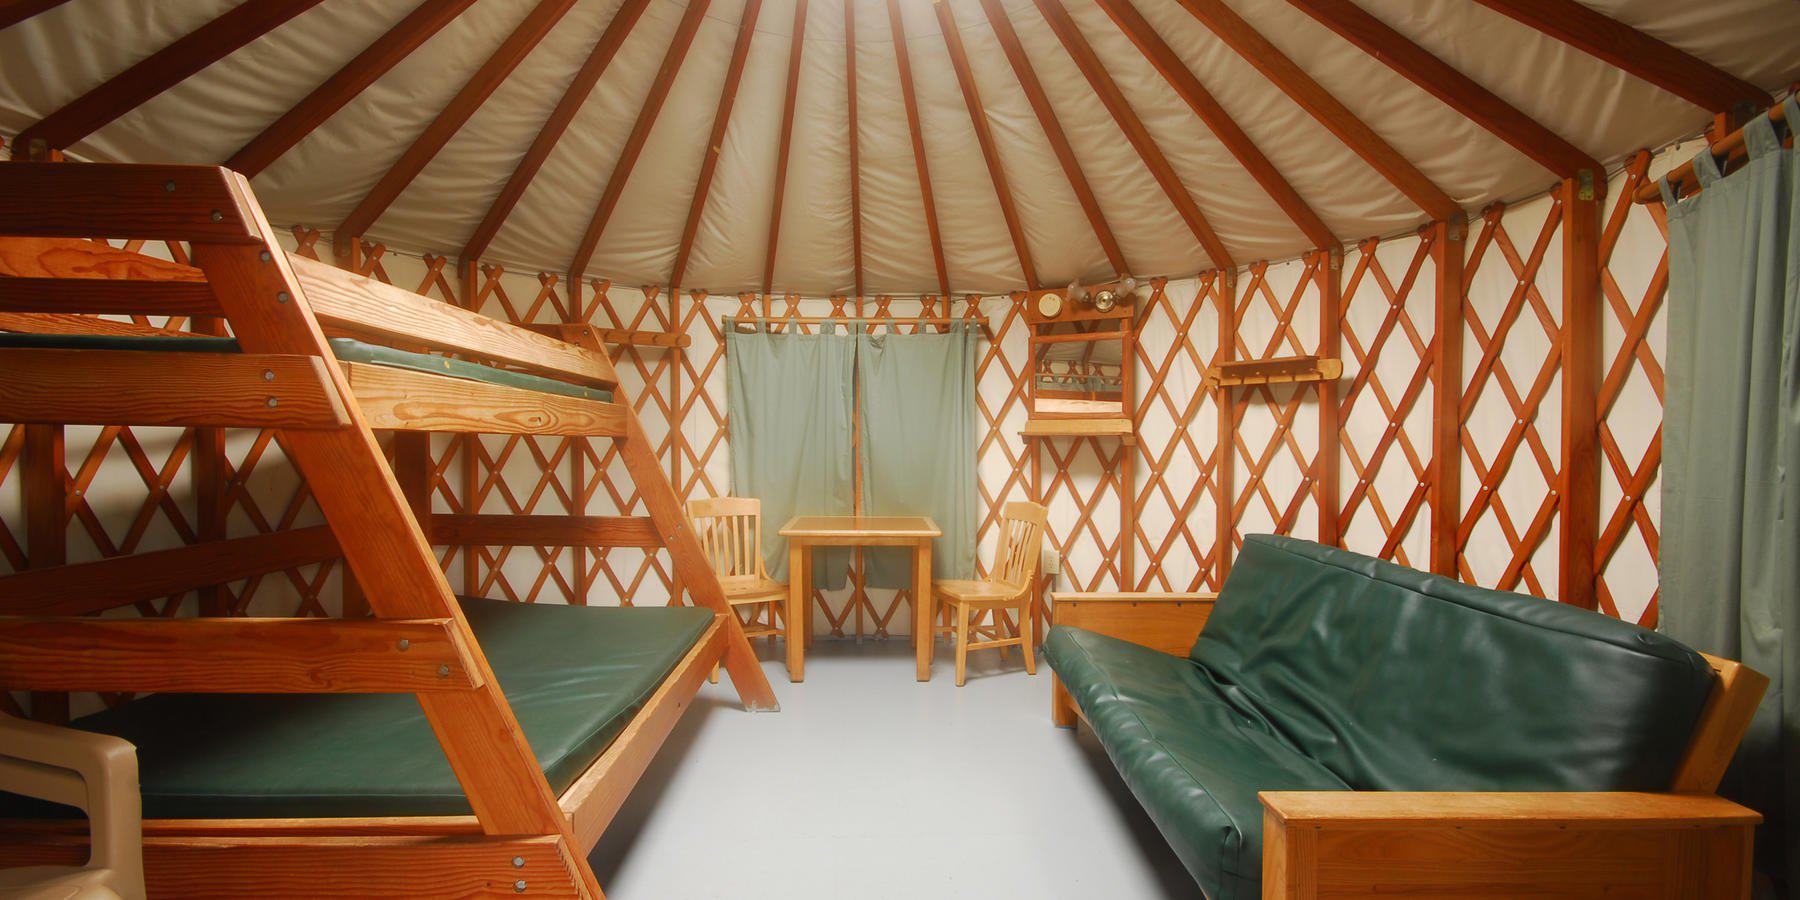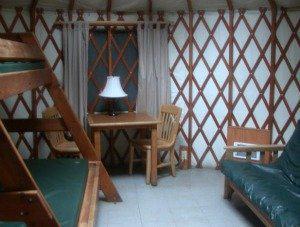The first image is the image on the left, the second image is the image on the right. For the images shown, is this caption "At least one image is of a sleeping area in a round house." true? Answer yes or no. Yes. The first image is the image on the left, the second image is the image on the right. Considering the images on both sides, is "At least one image shows a room with facing futon and angled bunk." valid? Answer yes or no. Yes. 